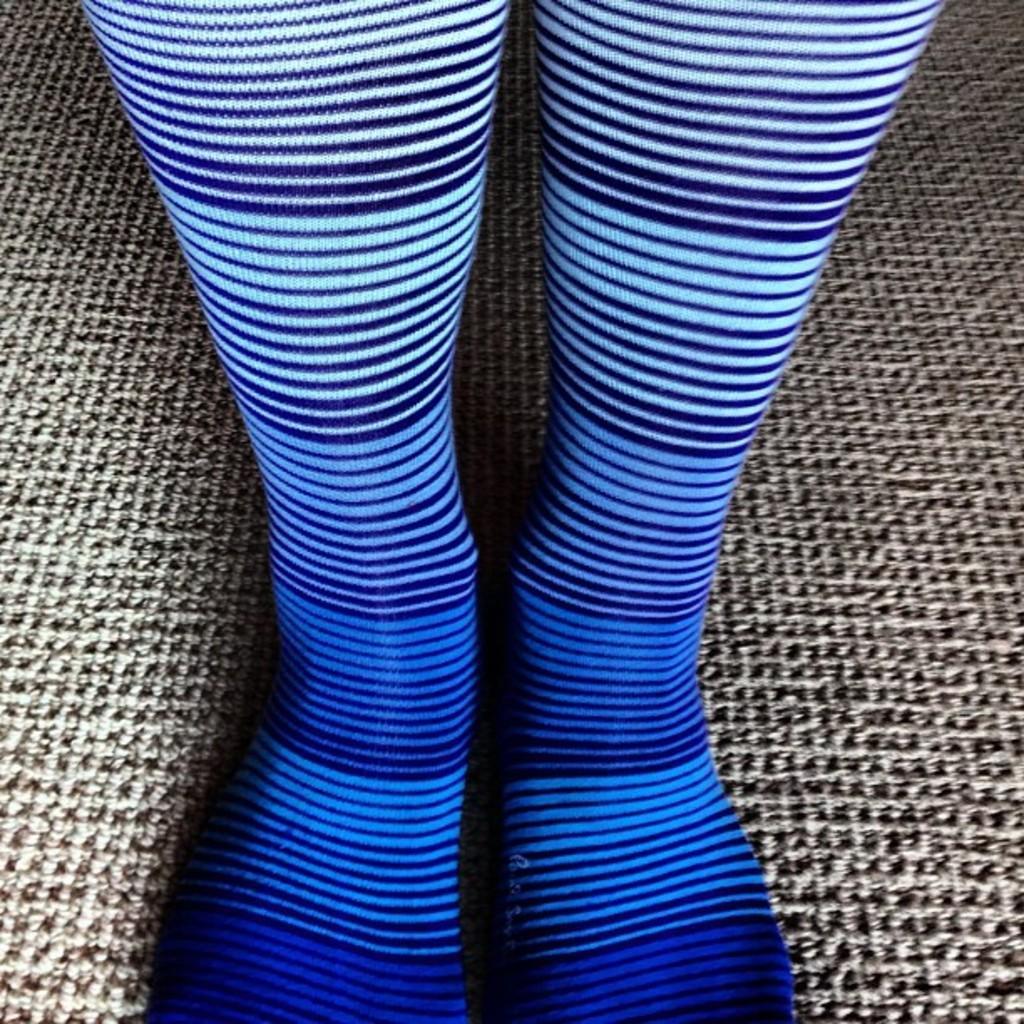Can you describe this image briefly? In this image I can see a person's legs on the floor. This image is taken may be in a room. 